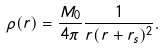<formula> <loc_0><loc_0><loc_500><loc_500>\rho ( r ) = \frac { M _ { 0 } } { 4 \pi } \frac { 1 } { r ( r + r _ { s } ) ^ { 2 } } .</formula> 